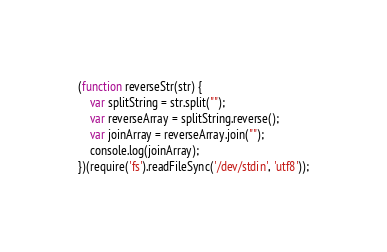Convert code to text. <code><loc_0><loc_0><loc_500><loc_500><_JavaScript_>(function reverseStr(str) {
    var splitString = str.split("");  
    var reverseArray = splitString.reverse(); 
    var joinArray = reverseArray.join("");     
    console.log(joinArray);
})(require('fs').readFileSync('/dev/stdin', 'utf8'));</code> 